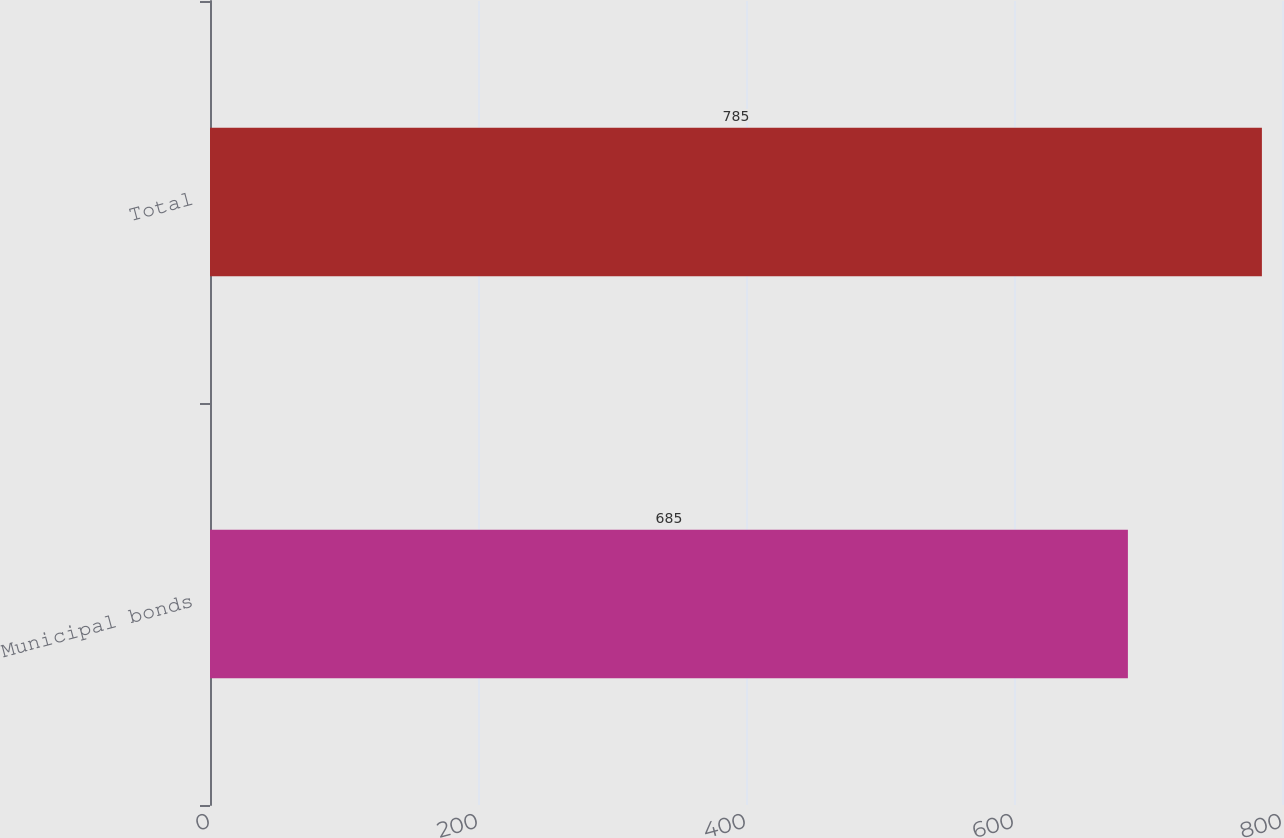<chart> <loc_0><loc_0><loc_500><loc_500><bar_chart><fcel>Municipal bonds<fcel>Total<nl><fcel>685<fcel>785<nl></chart> 